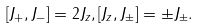<formula> <loc_0><loc_0><loc_500><loc_500>\left [ J _ { + } , J _ { - } \right ] = 2 J _ { z } , [ J _ { z } , J _ { \pm } ] = \pm J _ { \pm } .</formula> 